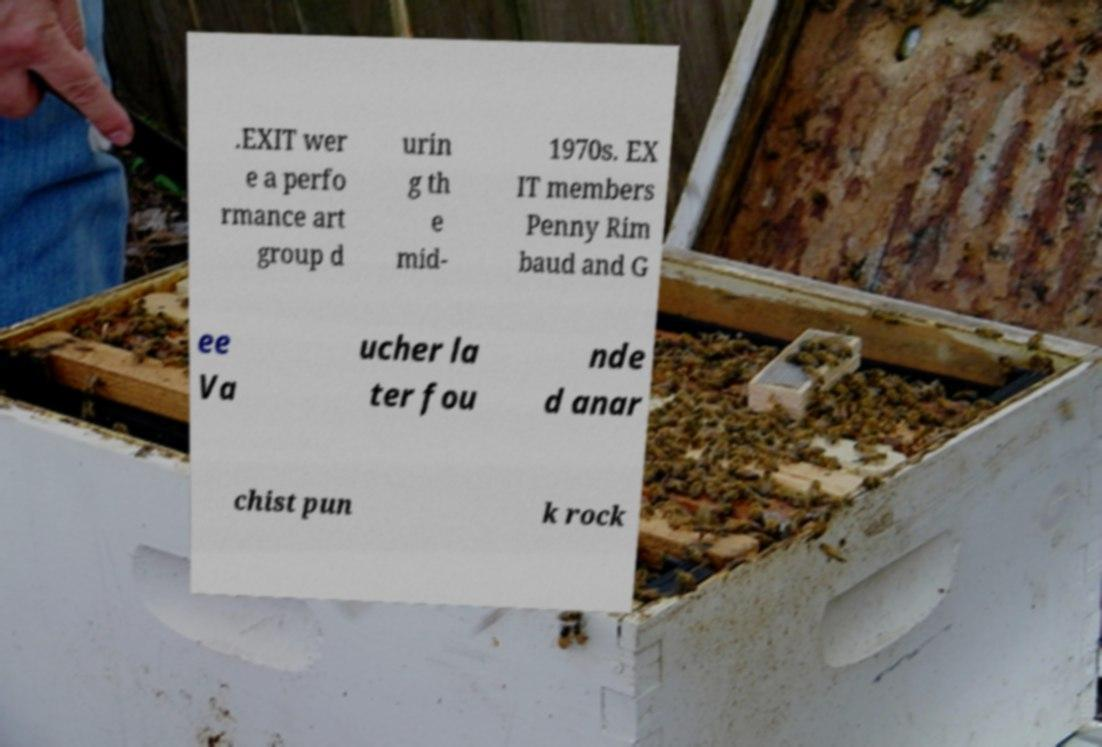I need the written content from this picture converted into text. Can you do that? .EXIT wer e a perfo rmance art group d urin g th e mid- 1970s. EX IT members Penny Rim baud and G ee Va ucher la ter fou nde d anar chist pun k rock 